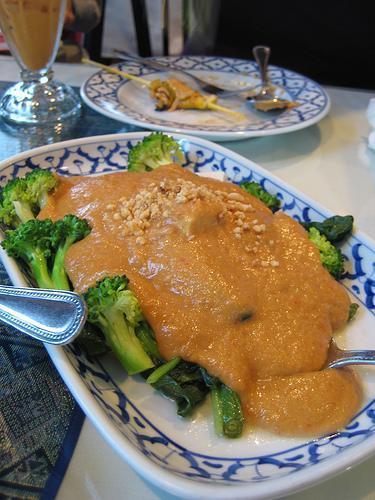How many plates are in the picture?
Give a very brief answer. 2. 